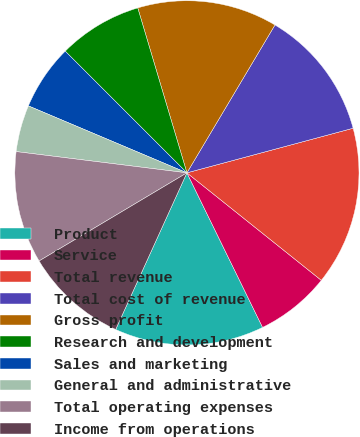Convert chart. <chart><loc_0><loc_0><loc_500><loc_500><pie_chart><fcel>Product<fcel>Service<fcel>Total revenue<fcel>Total cost of revenue<fcel>Gross profit<fcel>Research and development<fcel>Sales and marketing<fcel>General and administrative<fcel>Total operating expenses<fcel>Income from operations<nl><fcel>14.04%<fcel>7.02%<fcel>14.91%<fcel>12.28%<fcel>13.16%<fcel>7.89%<fcel>6.14%<fcel>4.39%<fcel>10.53%<fcel>9.65%<nl></chart> 